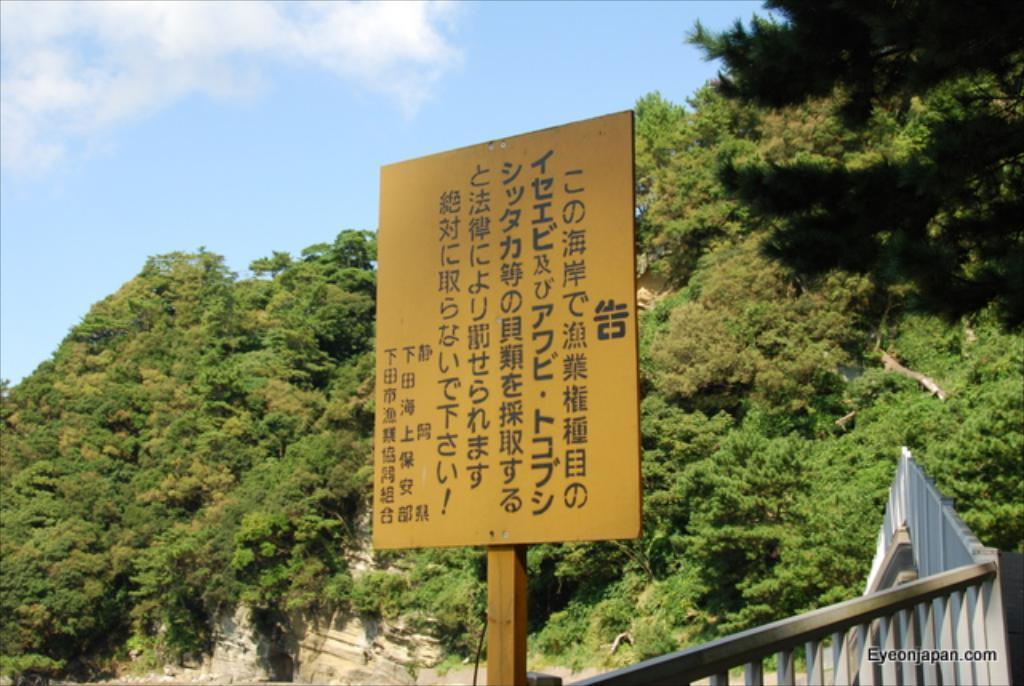What is the main object in the image? There is a board in the image. What is written on the board? There is text on the board. What can be seen near the board? There is a railing in the image. What is visible in the background of the image? Trees and the sky are visible in the background of the image. Where is the text located in the image? The text is present in the bottom right of the image. How many boys are playing with soap in the image? There are no boys or soap present in the image. 